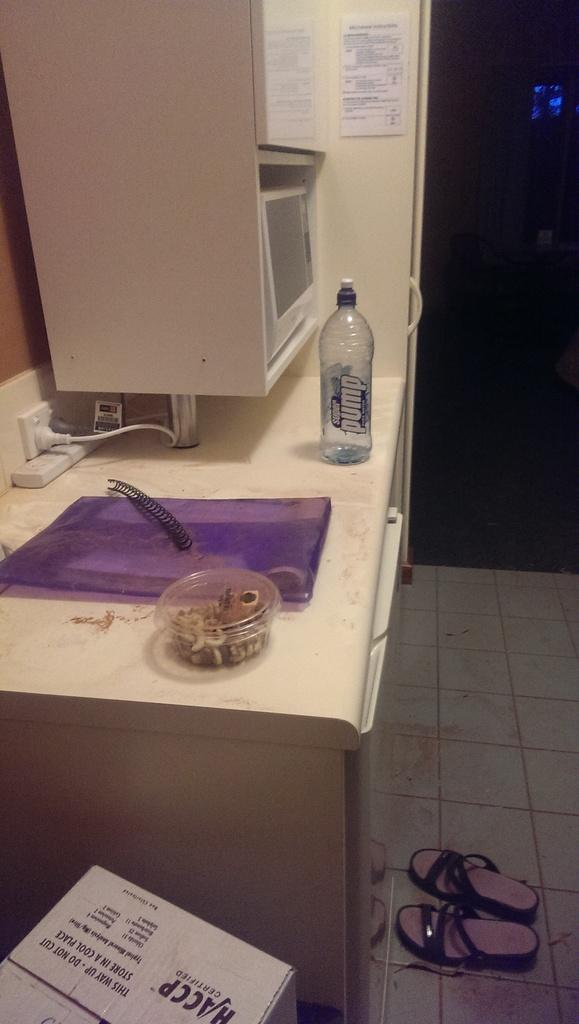<image>
Render a clear and concise summary of the photo. The contents of the white box needs to be stored in a cool place. 